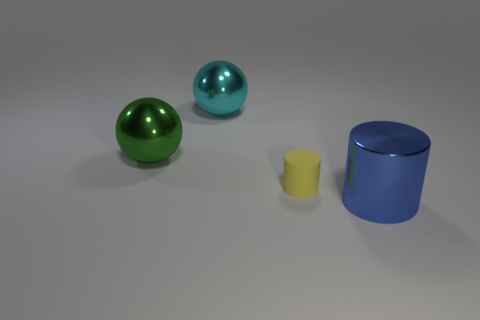What time of day does the lighting suggest in the scene? The image has a neutral lighting without strong directionality or shadows that might suggest a time of day. It appears to be a studio lighting setup, commonly used when rendering objects in 3D modeling software to provide even illumination. 